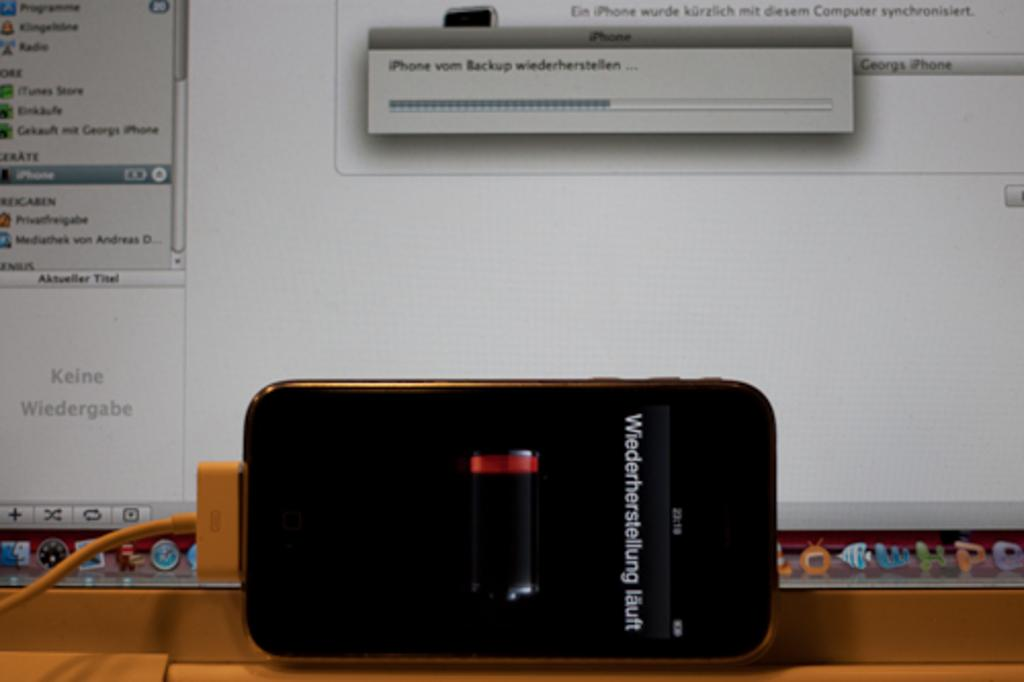<image>
Present a compact description of the photo's key features. An iPhone connected to a macbook running iPhone vom Backup wiederherstellen. 